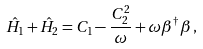<formula> <loc_0><loc_0><loc_500><loc_500>\hat { H } _ { 1 } + \hat { H } _ { 2 } = C _ { 1 } - \frac { C _ { 2 } ^ { 2 } } { \omega } + \omega \beta ^ { \dag } \beta \, ,</formula> 